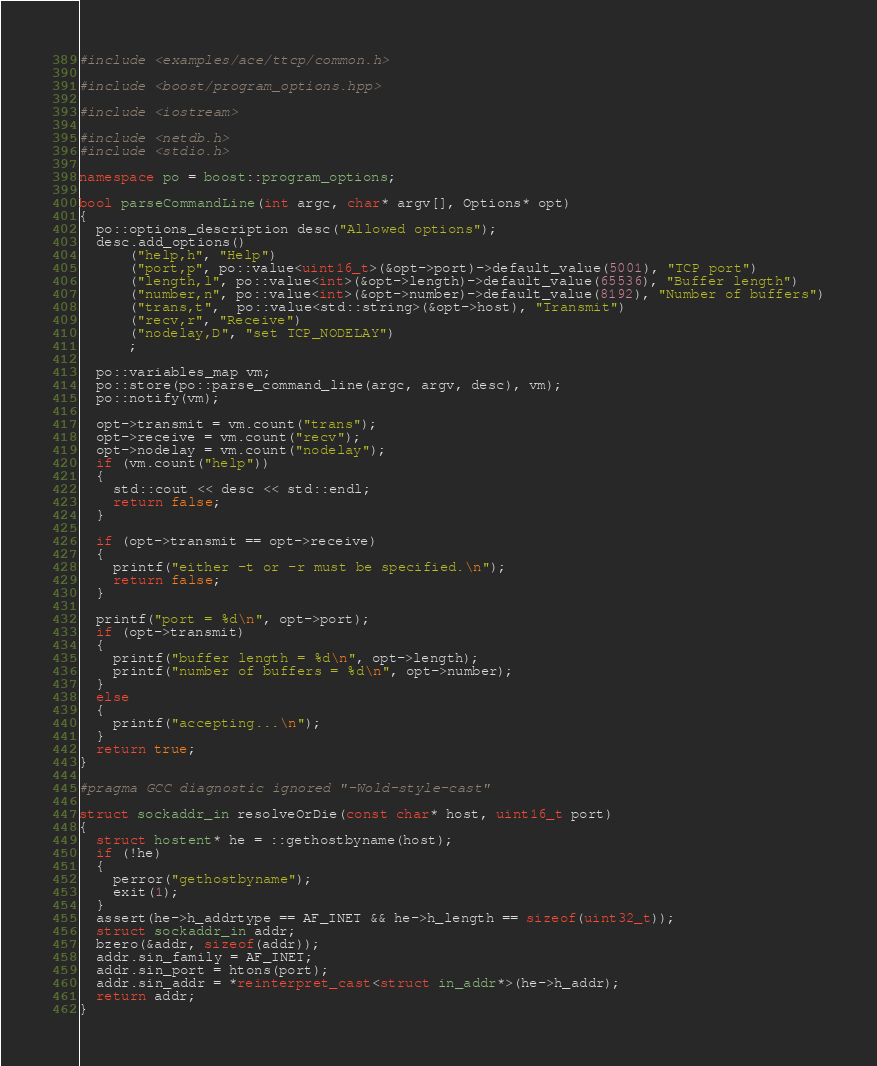<code> <loc_0><loc_0><loc_500><loc_500><_C++_>#include <examples/ace/ttcp/common.h>

#include <boost/program_options.hpp>

#include <iostream>

#include <netdb.h>
#include <stdio.h>

namespace po = boost::program_options;

bool parseCommandLine(int argc, char* argv[], Options* opt)
{
  po::options_description desc("Allowed options");
  desc.add_options()
      ("help,h", "Help")
      ("port,p", po::value<uint16_t>(&opt->port)->default_value(5001), "TCP port")
      ("length,l", po::value<int>(&opt->length)->default_value(65536), "Buffer length")
      ("number,n", po::value<int>(&opt->number)->default_value(8192), "Number of buffers")
      ("trans,t",  po::value<std::string>(&opt->host), "Transmit")
      ("recv,r", "Receive")
      ("nodelay,D", "set TCP_NODELAY")
      ;

  po::variables_map vm;
  po::store(po::parse_command_line(argc, argv, desc), vm);
  po::notify(vm);

  opt->transmit = vm.count("trans");
  opt->receive = vm.count("recv");
  opt->nodelay = vm.count("nodelay");
  if (vm.count("help"))
  {
    std::cout << desc << std::endl;
    return false;
  }

  if (opt->transmit == opt->receive)
  {
    printf("either -t or -r must be specified.\n");
    return false;
  }

  printf("port = %d\n", opt->port);
  if (opt->transmit)
  {
    printf("buffer length = %d\n", opt->length);
    printf("number of buffers = %d\n", opt->number);
  }
  else
  {
    printf("accepting...\n");
  }
  return true;
}

#pragma GCC diagnostic ignored "-Wold-style-cast"

struct sockaddr_in resolveOrDie(const char* host, uint16_t port)
{
  struct hostent* he = ::gethostbyname(host);
  if (!he)
  {
    perror("gethostbyname");
    exit(1);
  }
  assert(he->h_addrtype == AF_INET && he->h_length == sizeof(uint32_t));
  struct sockaddr_in addr;
  bzero(&addr, sizeof(addr));
  addr.sin_family = AF_INET;
  addr.sin_port = htons(port);
  addr.sin_addr = *reinterpret_cast<struct in_addr*>(he->h_addr);
  return addr;
}

</code> 